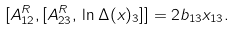<formula> <loc_0><loc_0><loc_500><loc_500>[ A ^ { R } _ { 1 2 } , [ A ^ { R } _ { 2 3 } , \, \ln \Delta ( x ) _ { 3 } ] ] = 2 b _ { 1 3 } x _ { 1 3 } .</formula> 